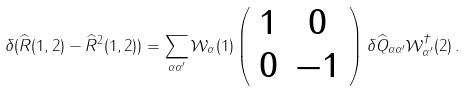Convert formula to latex. <formula><loc_0><loc_0><loc_500><loc_500>\delta ( \widehat { R } ( 1 , 2 ) - { \widehat { R } } ^ { 2 } ( 1 , 2 ) ) = \sum _ { \alpha \alpha ^ { \prime } } { \mathcal { W } } _ { \alpha } ( 1 ) \left ( \begin{array} { c c } 1 & 0 \\ 0 & - 1 \end{array} \right ) \delta { \widehat { Q } } _ { \alpha \alpha ^ { \prime } } { \mathcal { W } } ^ { \dagger } _ { \alpha ^ { \prime } } ( 2 ) \, .</formula> 